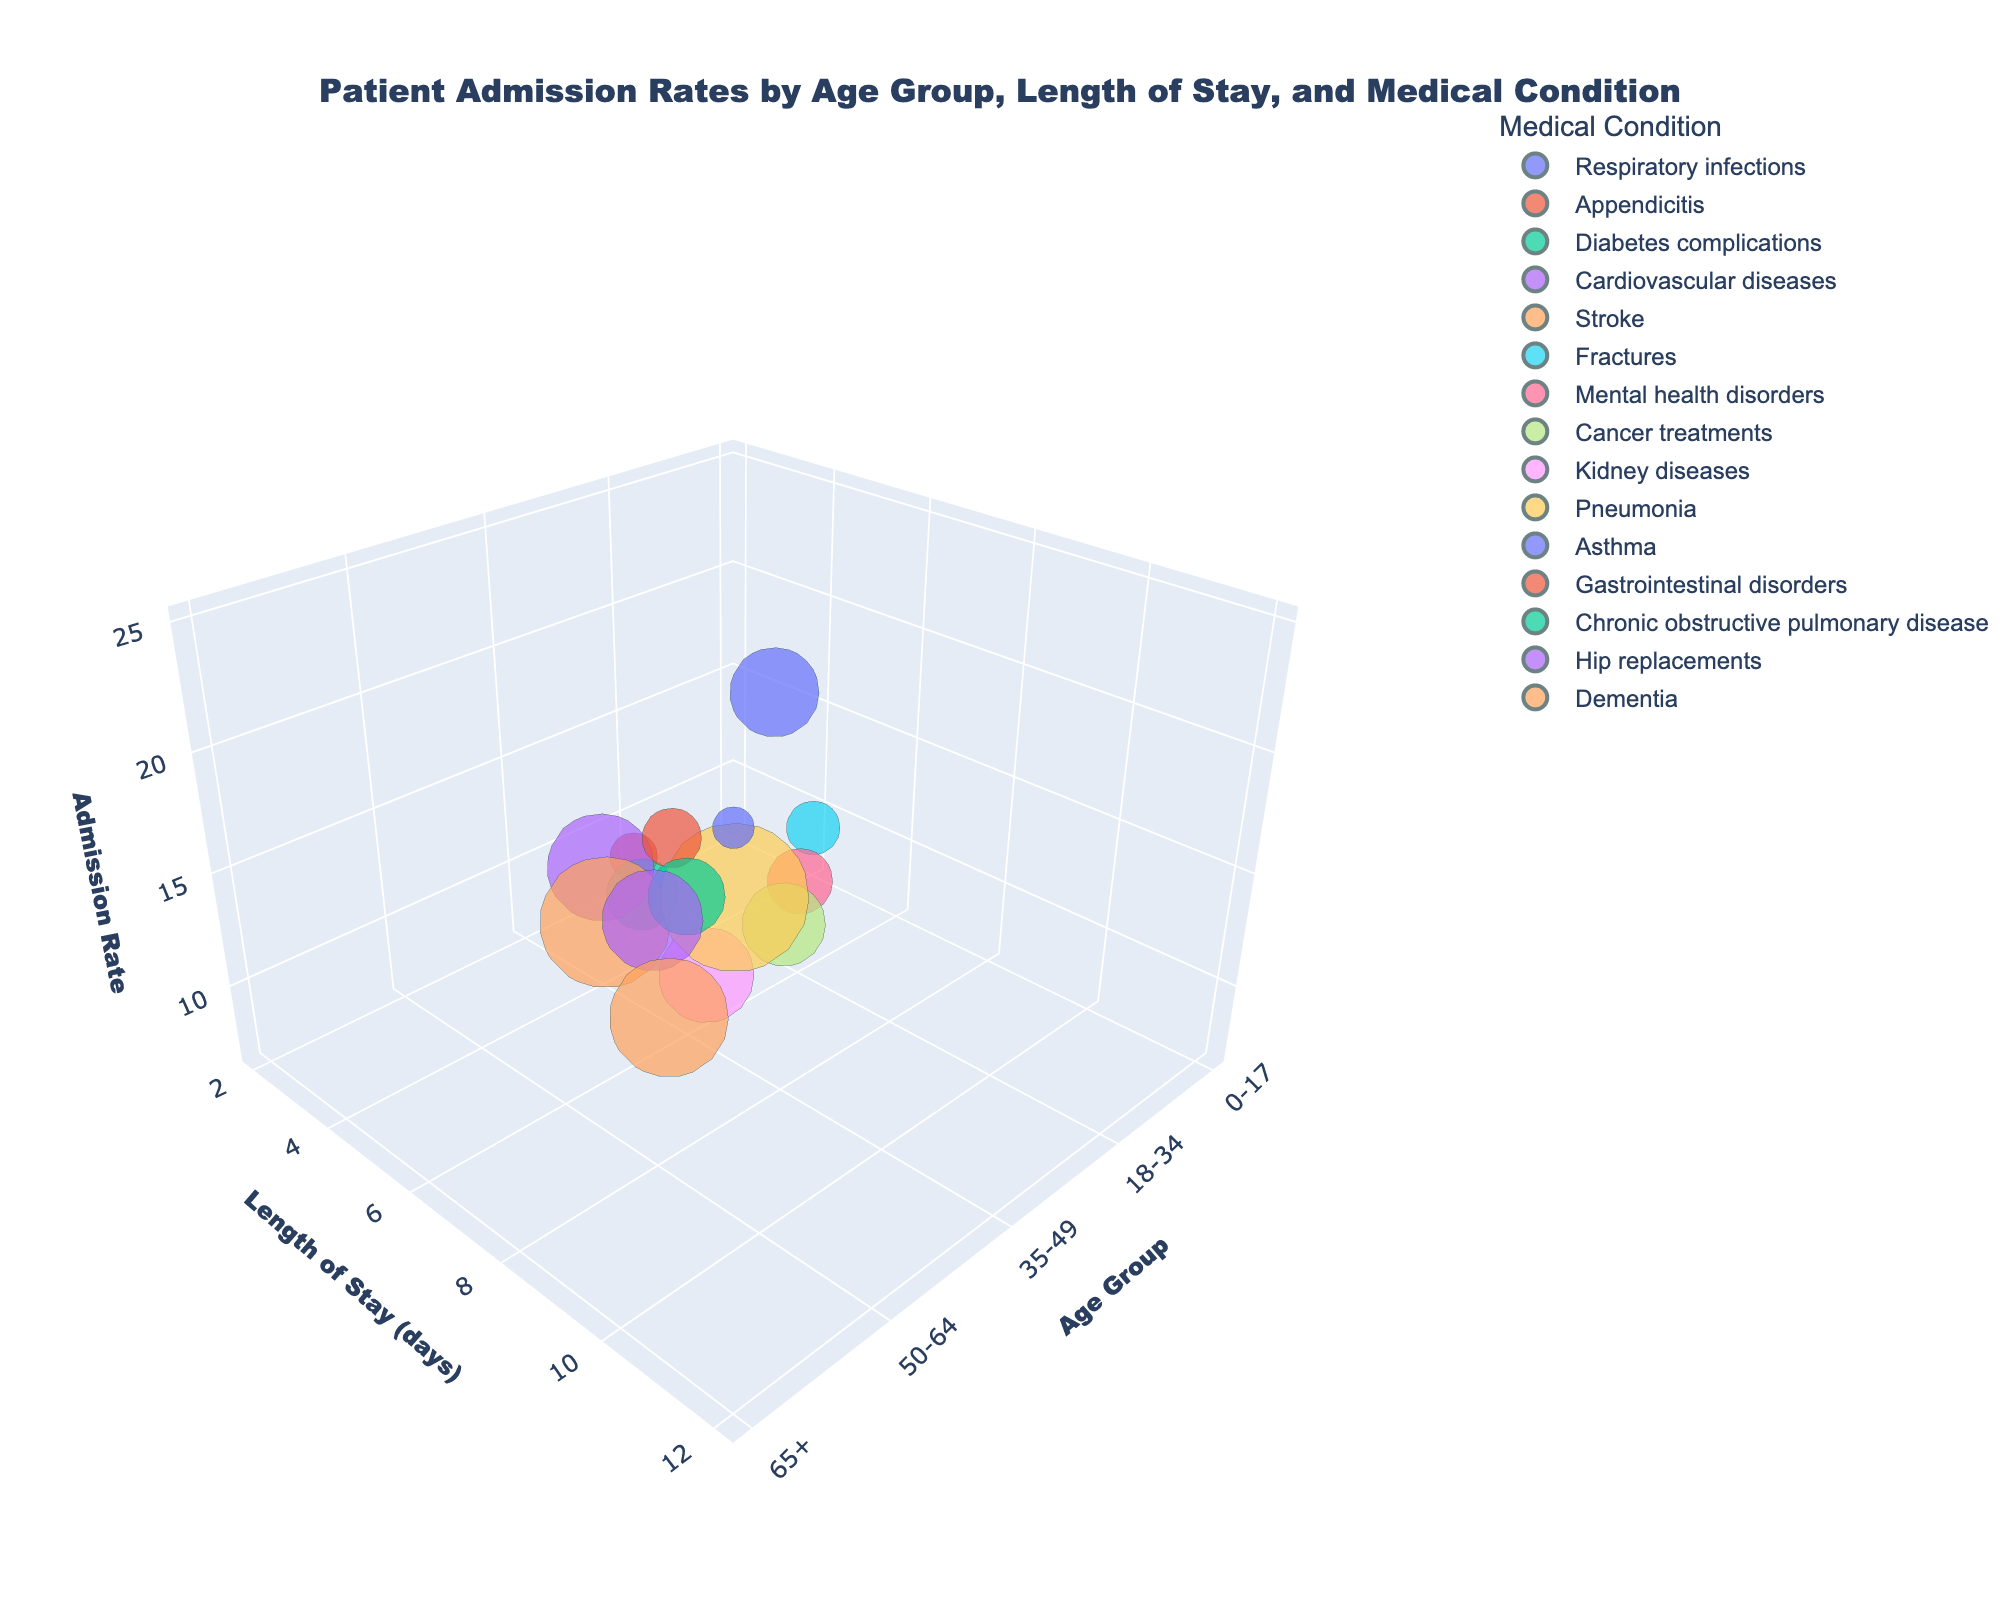What's the title of the chart? The title is displayed at the top of the chart which summarizes its content. The title reads "Patient Admission Rates by Age Group, Length of Stay, and Medical Condition".
Answer: Patient Admission Rates by Age Group, Length of Stay, and Medical Condition How many different age groups are represented in this chart? The x-axis represents different age groups. Observing the labels on the x-axis reveals there are five distinct age groups: 0-17, 18-34, 35-49, 50-64, and 65+.
Answer: 5 Which medical condition has the highest admission rate? By observing the positioning and size of bubbles along the z-axis (Admission Rate), the medical condition with the largest bubble at the highest z-axis value represents the highest admission rate. This condition is Pneumonia.
Answer: Pneumonia What is the length of stay for patients aged 65+ with Pneumonia? To determine this, find the bubble associated with "Pneumonia" within the 65+ age group and check its position on the y-axis. The bubble is positioned at 12 days.
Answer: 12 days Compare the admission rates for Diabetes complications and Kidney diseases. Which has a higher rate and by how much? Identify the corresponding bubbles for "Diabetes complications" and "Kidney diseases" and compare their z-values (admission rates). Diabetes complications have a rate of 12, while Kidney diseases have a rate of 16. The difference is 16 - 12.
Answer: Kidney diseases, by 4 What's the average length of stay for medical conditions in the age group 35-49? Identify the lengths of stay y-values for this age group: Diabetes complications (5), Cancer treatments (8), and Chronic obstructive pulmonary disease (6). Calculate their average: (5 + 8 + 6) / 3 = 6.33.
Answer: 6.33 days Which age group has the most diverse range of medical conditions? By checking the distribution and the number of different colored bubbles within each age group on the x-axis. The age group 18-34 has conditions like Appendicitis, Mental health disorders, and Gastrointestinal disorders, making it the most diverse in this dataset.
Answer: 18-34 What is the admission rate and length of stay for patients aged 0-17 with Fractures? Find the bubble corresponding to "Fractures" within the 0-17 age group. The z-axis value (admission rate) is 9, and the y-axis value (length of stay) is 4 days.
Answer: Admission rate: 9, Length of stay: 4 days 